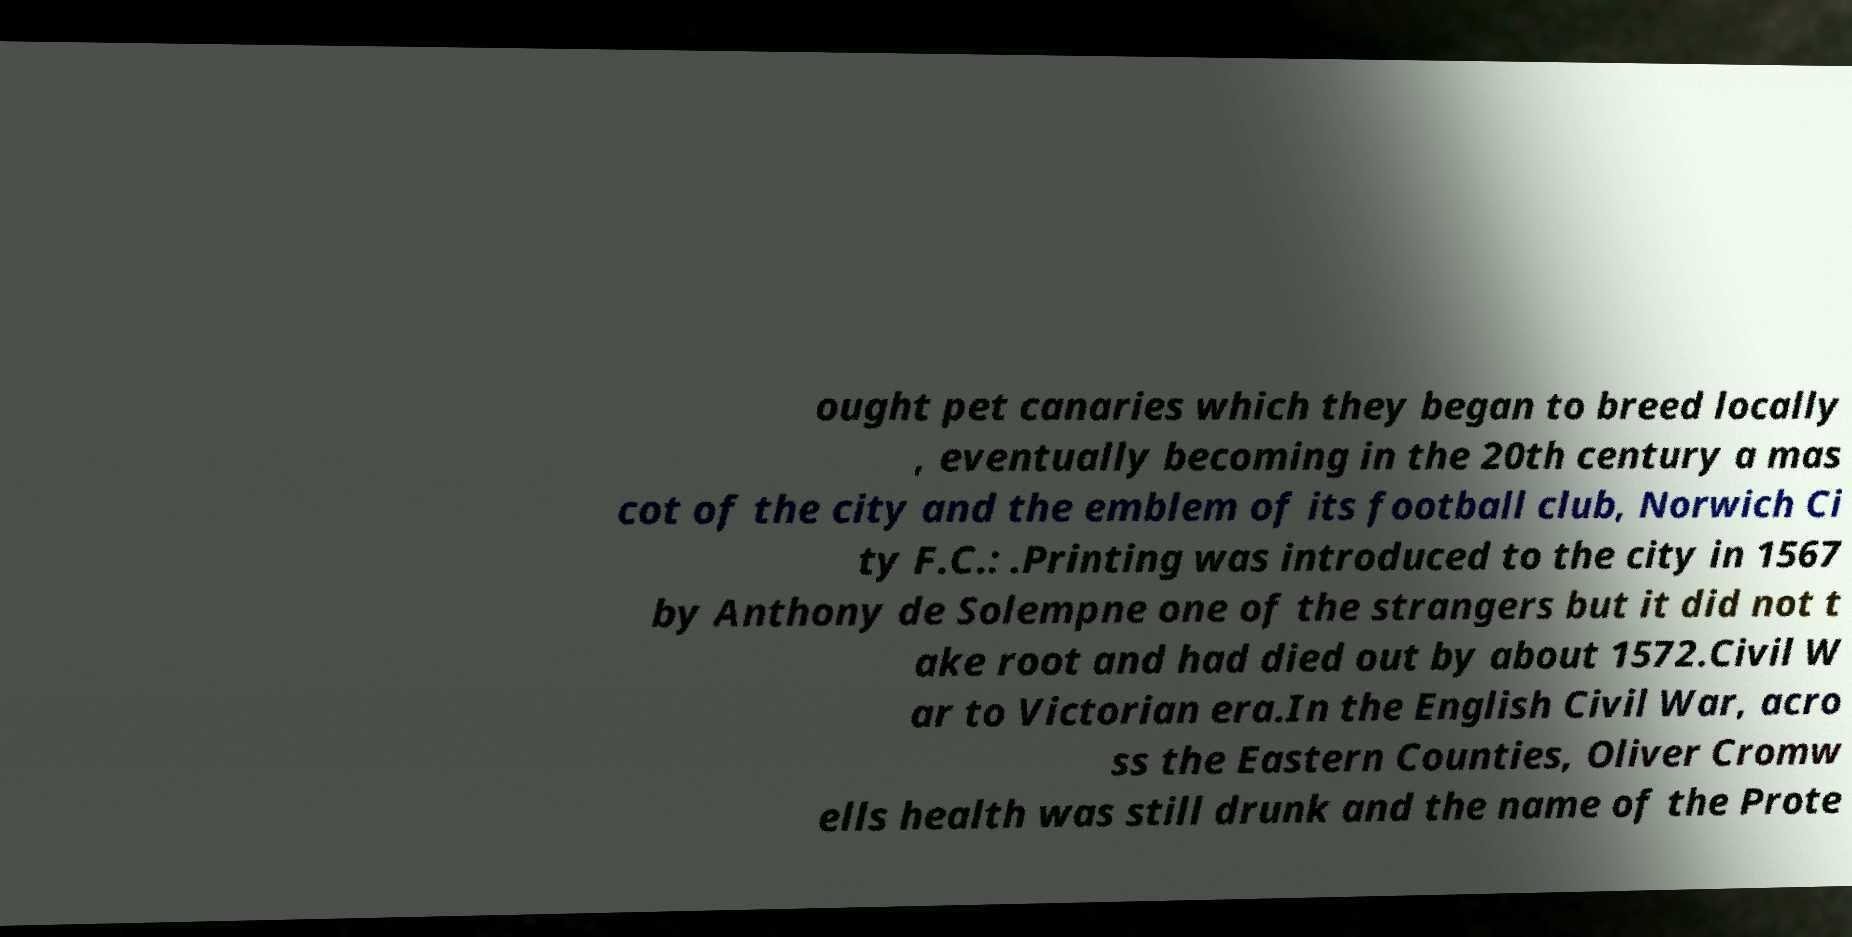Please identify and transcribe the text found in this image. ought pet canaries which they began to breed locally , eventually becoming in the 20th century a mas cot of the city and the emblem of its football club, Norwich Ci ty F.C.: .Printing was introduced to the city in 1567 by Anthony de Solempne one of the strangers but it did not t ake root and had died out by about 1572.Civil W ar to Victorian era.In the English Civil War, acro ss the Eastern Counties, Oliver Cromw ells health was still drunk and the name of the Prote 